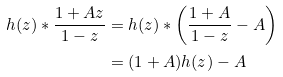<formula> <loc_0><loc_0><loc_500><loc_500>h ( z ) * \frac { 1 + A z } { 1 - z } & = h ( z ) * \left ( \frac { 1 + A } { 1 - z } - A \right ) \\ & = ( 1 + A ) h ( z ) - A</formula> 